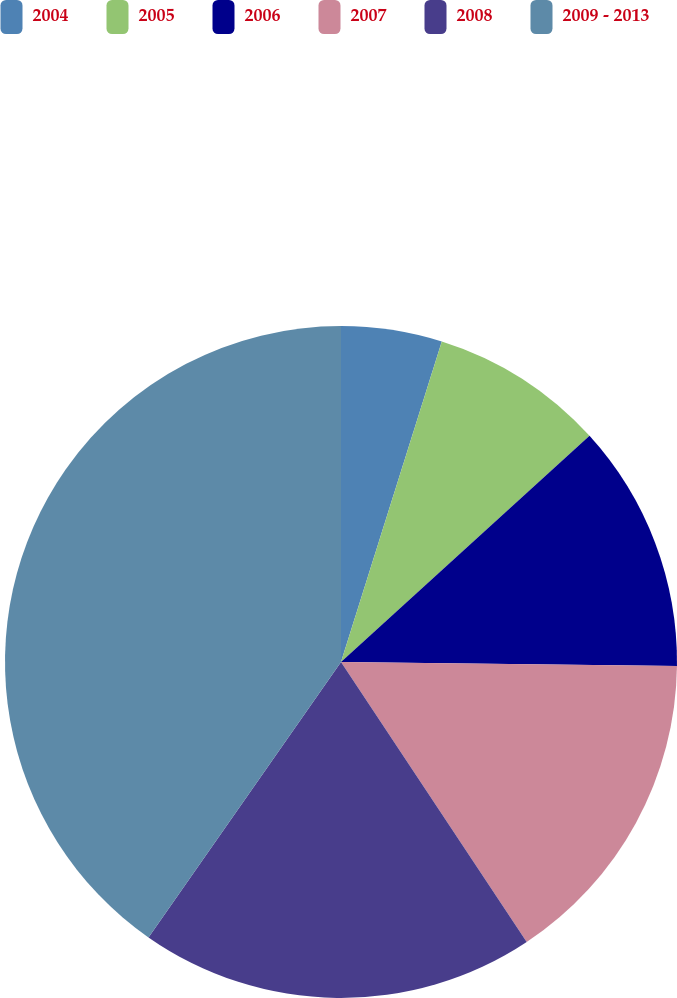<chart> <loc_0><loc_0><loc_500><loc_500><pie_chart><fcel>2004<fcel>2005<fcel>2006<fcel>2007<fcel>2008<fcel>2009 - 2013<nl><fcel>4.85%<fcel>8.4%<fcel>11.94%<fcel>15.49%<fcel>19.03%<fcel>40.29%<nl></chart> 